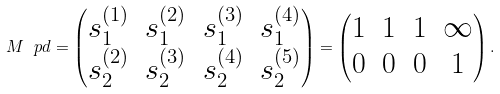<formula> <loc_0><loc_0><loc_500><loc_500>M ^ { \ } p d = \begin{pmatrix} s _ { 1 } ^ { ( 1 ) } & s _ { 1 } ^ { ( 2 ) } & s _ { 1 } ^ { ( 3 ) } & s _ { 1 } ^ { ( 4 ) } \\ s _ { 2 } ^ { ( 2 ) } & s _ { 2 } ^ { ( 3 ) } & s _ { 2 } ^ { ( 4 ) } & s _ { 2 } ^ { ( 5 ) } \end{pmatrix} = \begin{pmatrix} 1 & 1 & 1 & \infty \\ 0 & 0 & 0 & 1 \end{pmatrix} .</formula> 